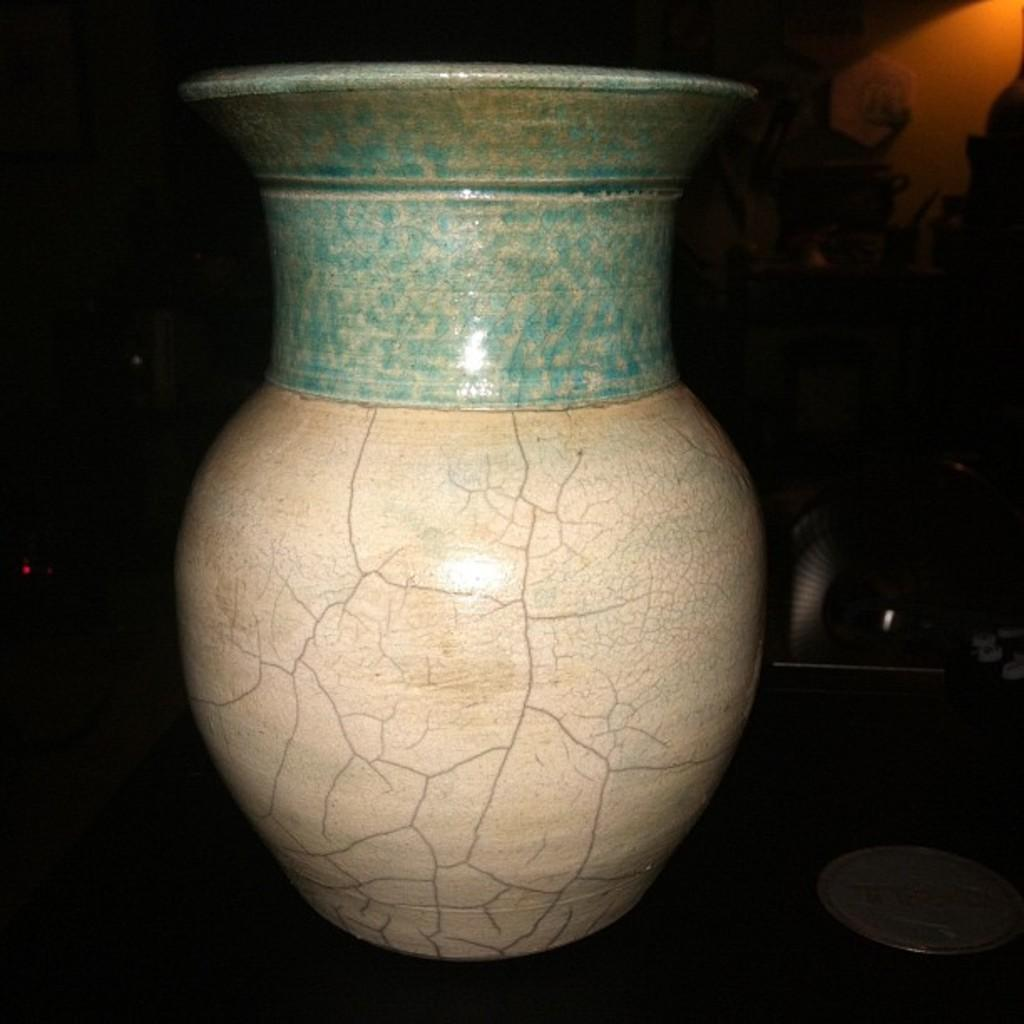What object can be seen in the image? There is a vase in the image. What can be observed about the background of the image? The background of the image is dark. What type of lipstick is the crow using in the image? There is no lipstick or crow present in the image; it only features a vase and a dark background. How many apples are on the vase in the image? There are no apples present in the image; it only features a vase. 